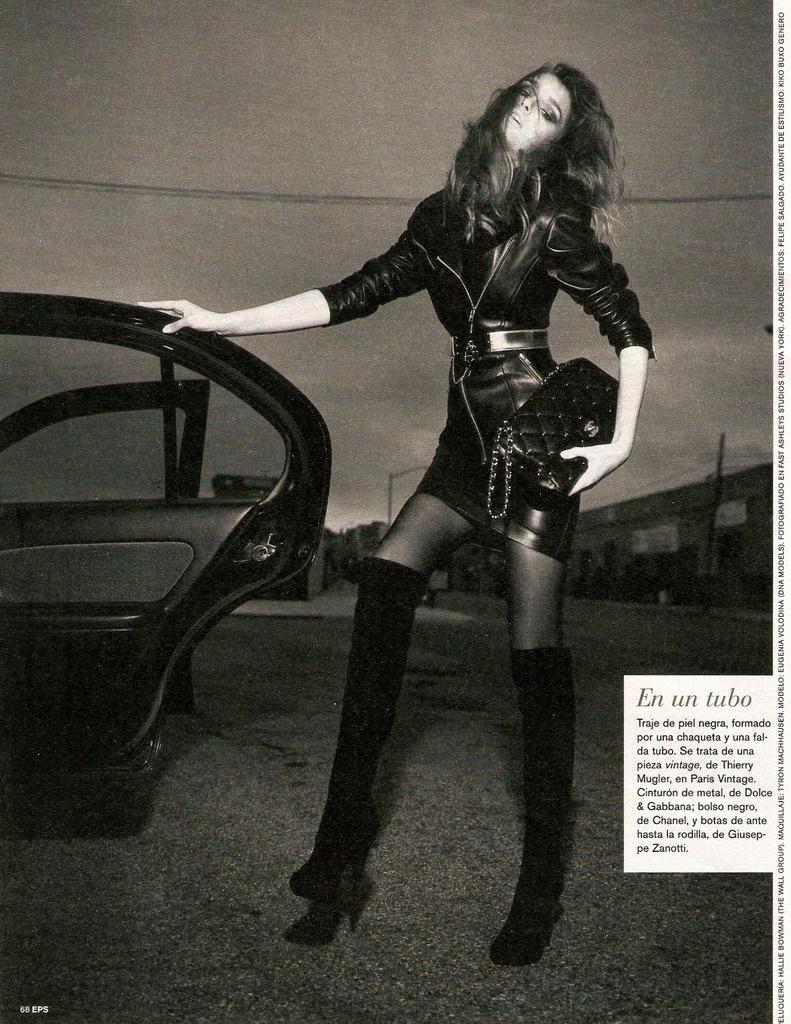Could you give a brief overview of what you see in this image? This is a black and white image. In this image there is a lady holding a bag. She is holding the door of a vehicle. On the right side something is written. In the background there is sky. 